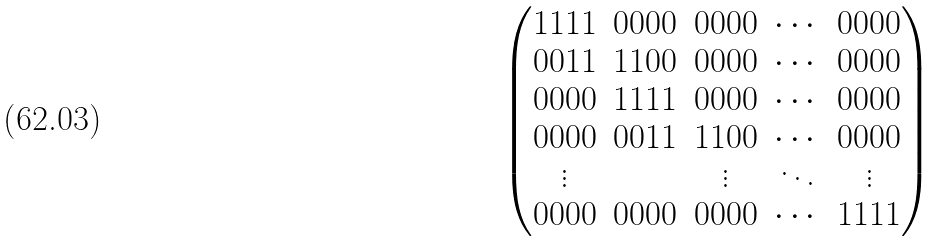<formula> <loc_0><loc_0><loc_500><loc_500>\begin{pmatrix} 1 1 1 1 & 0 0 0 0 & 0 0 0 0 & \cdots & 0 0 0 0 \\ 0 0 1 1 & 1 1 0 0 & 0 0 0 0 & \cdots & 0 0 0 0 \\ 0 0 0 0 & 1 1 1 1 & 0 0 0 0 & \cdots & 0 0 0 0 \\ 0 0 0 0 & 0 0 1 1 & 1 1 0 0 & \cdots & 0 0 0 0 \\ \vdots & & \vdots & \ddots & \vdots \\ 0 0 0 0 & 0 0 0 0 & 0 0 0 0 & \cdots & 1 1 1 1 \end{pmatrix}</formula> 